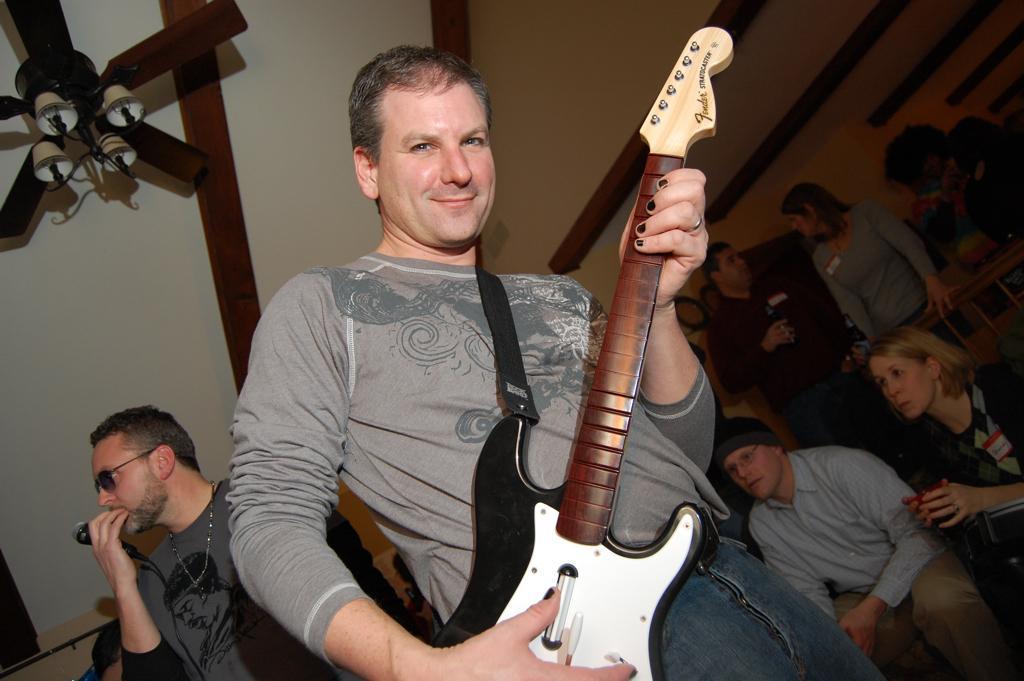Can you describe this image briefly? In the middle of the image a man standing and holding a guitar and smiling. Bottom right side of the image a few people are there. Top right side of the image there is a roof. Bottom left side of the image a man standing and holding a microphone. Top left side of the image there is a fan. 